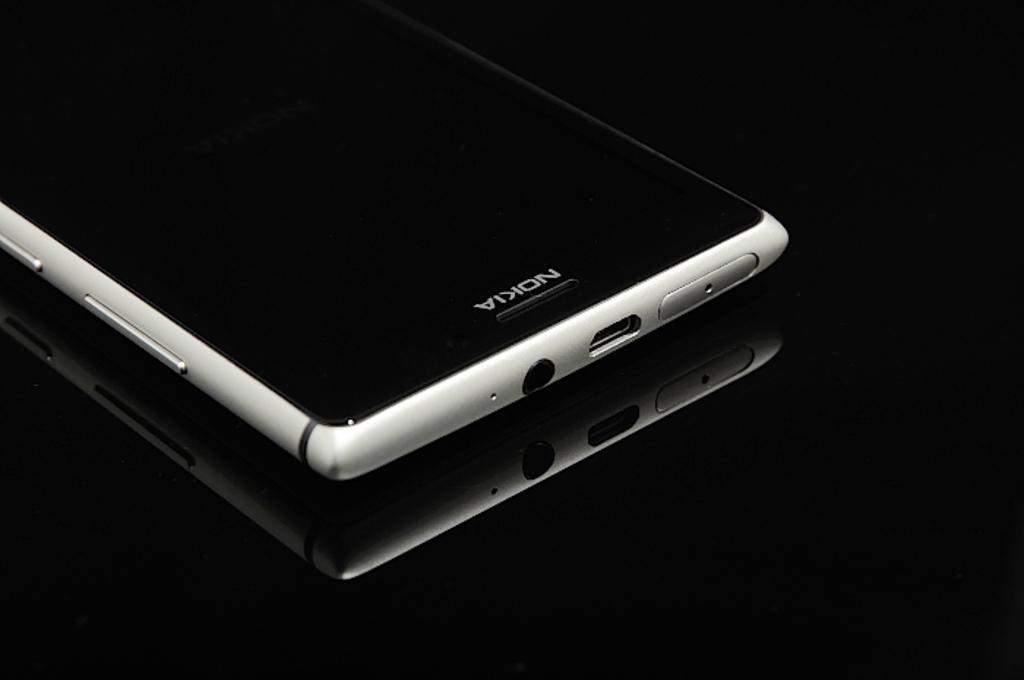What type of mobile is visible in the image? There is a Nokia mobile with buttons in the image. Can you describe the reflection in the image? There is a reflection of a mobile on an object in the image. What is the color of the background in the image? The background of the image is dark. What type of food is being served in the lunchroom in the image? There is no lunchroom or food present in the image. How does the mobile affect the person's throat in the image? There is no person or throat mentioned in the image; it only features a mobile and its reflection. 